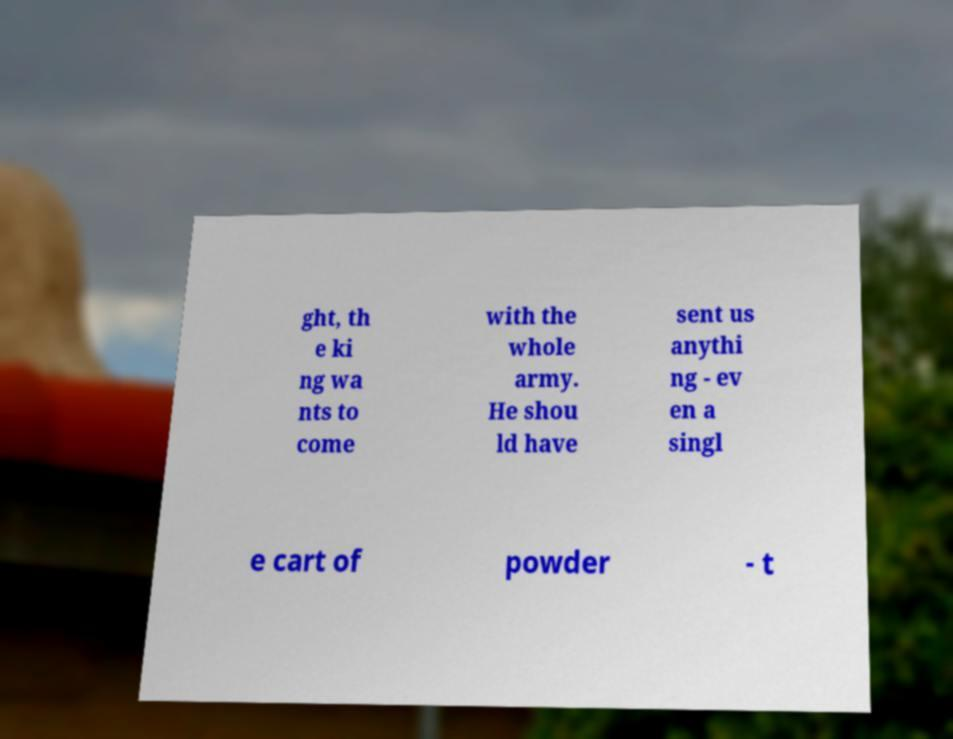Can you read and provide the text displayed in the image?This photo seems to have some interesting text. Can you extract and type it out for me? ght, th e ki ng wa nts to come with the whole army. He shou ld have sent us anythi ng - ev en a singl e cart of powder - t 